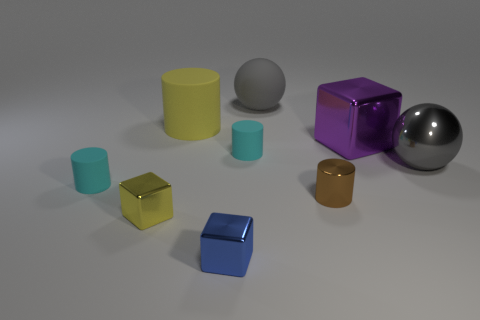Is the material of the small cyan cylinder to the left of the yellow rubber cylinder the same as the tiny yellow cube?
Provide a succinct answer. No. There is a blue block that is the same size as the brown cylinder; what material is it?
Offer a very short reply. Metal. How many other things are the same material as the big cube?
Your response must be concise. 4. Does the cyan thing left of the blue metal cube have the same shape as the large rubber thing left of the matte sphere?
Offer a very short reply. Yes. What number of other things are there of the same color as the large rubber ball?
Provide a short and direct response. 1. Do the gray thing that is right of the large purple metal cube and the big sphere that is behind the yellow matte cylinder have the same material?
Provide a succinct answer. No. Is the number of tiny cyan rubber cylinders that are on the right side of the tiny yellow metal thing the same as the number of big yellow cylinders that are in front of the tiny metallic cylinder?
Ensure brevity in your answer.  No. What material is the large gray ball to the right of the tiny metallic cylinder?
Offer a terse response. Metal. Are there fewer brown metallic cylinders than matte cylinders?
Your answer should be compact. Yes. What is the shape of the metallic object that is both right of the yellow block and to the left of the rubber sphere?
Ensure brevity in your answer.  Cube. 